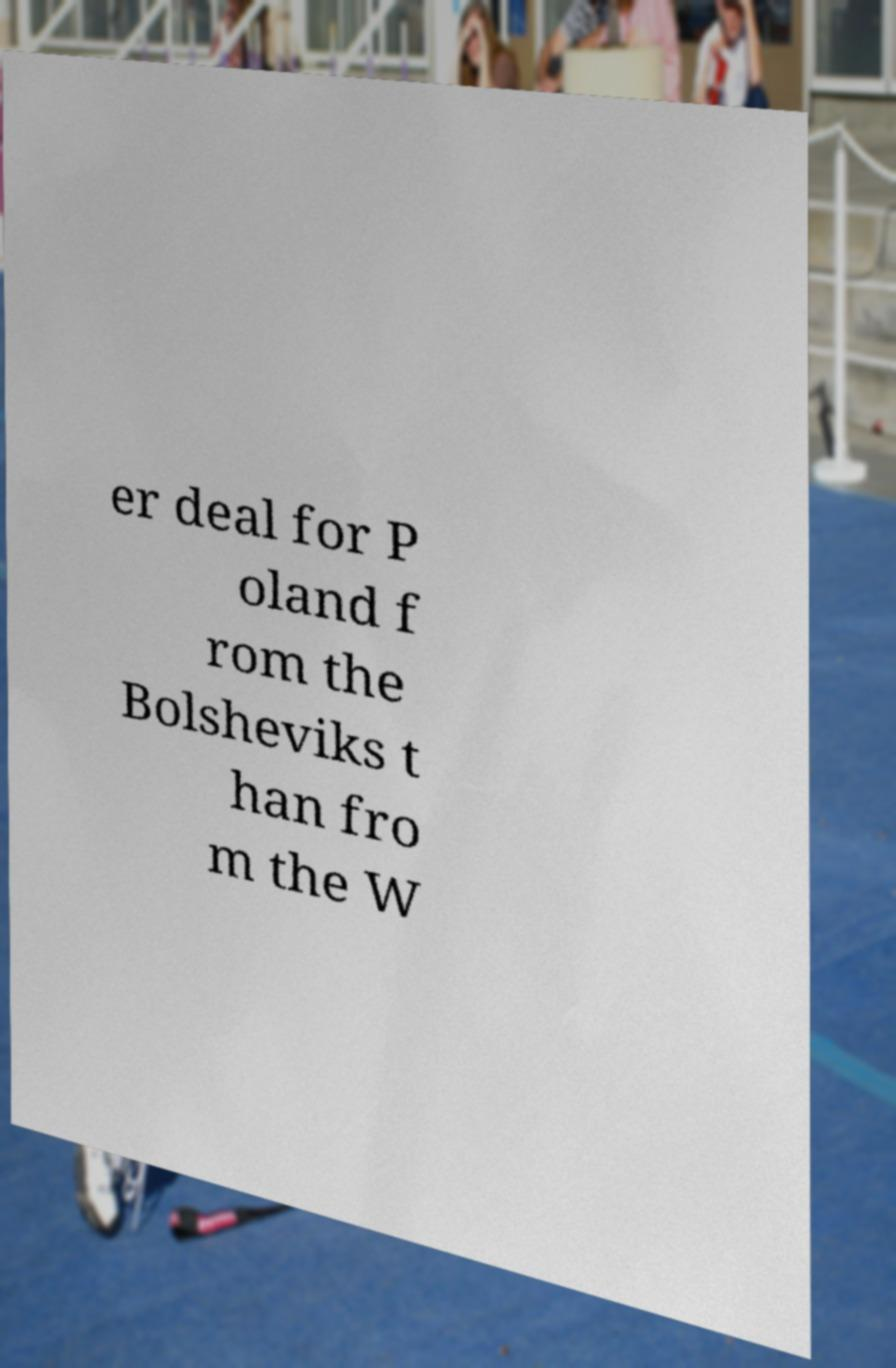For documentation purposes, I need the text within this image transcribed. Could you provide that? er deal for P oland f rom the Bolsheviks t han fro m the W 